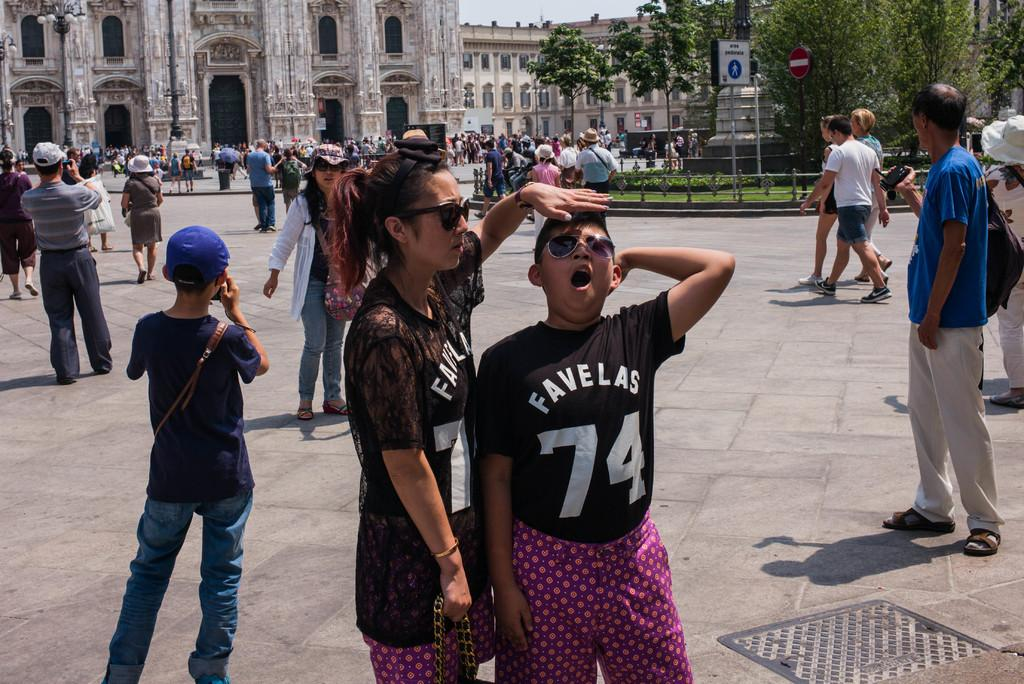What is happening in the foreground of the image? There is a crowd on the road in the foreground. What is located between the crowd and the background? There is a fence in the foreground. What can be seen in the background of the image? Buildings, windows, trees, sign boards, and the sky are visible in the background. Can you describe the time of day when the image might have been taken? The image might have been taken during the day, as the sky is visible. What type of zephyr is blowing through the crowd in the image? There is no mention of a zephyr or any wind in the image. Can you tell me what the grandfather is doing in the image? There is no mention of a grandfather or any person in the image. 